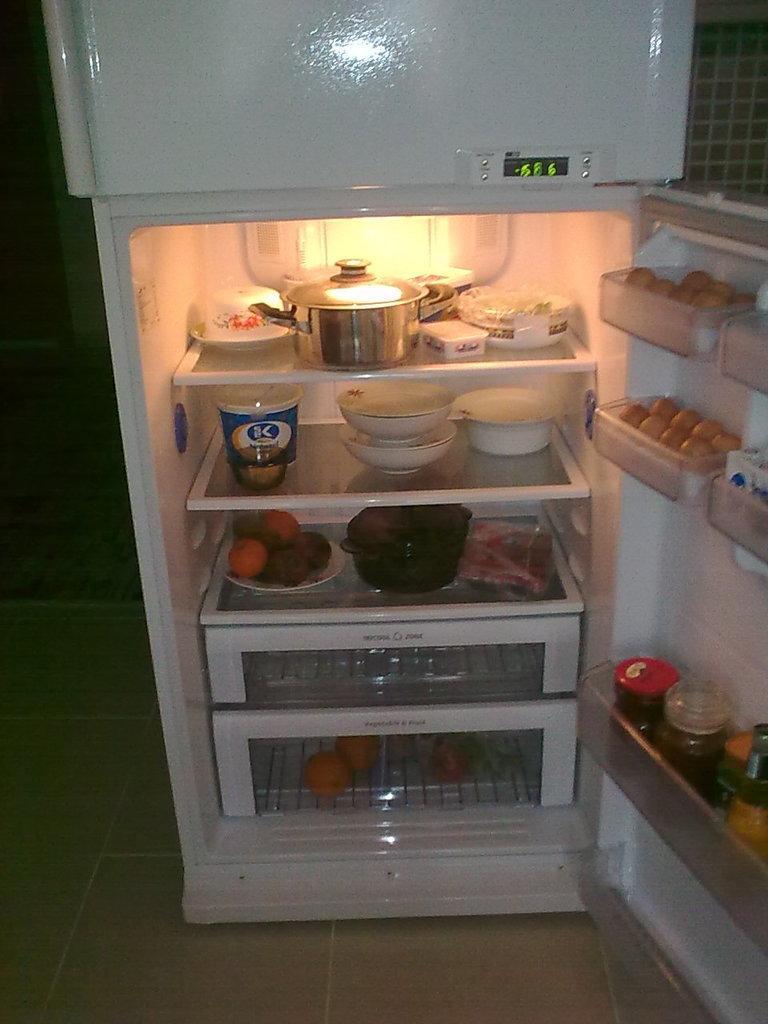How would you summarize this image in a sentence or two? In this image we can see one white refrigerator on the floor. There are some eggs, some bowls, some bottles, some boxes, fruits and some objects in the refrigerator. One object on the top right side of the image, some numbers on the refrigerator, some objects on the left side of the image and the background is dark. 